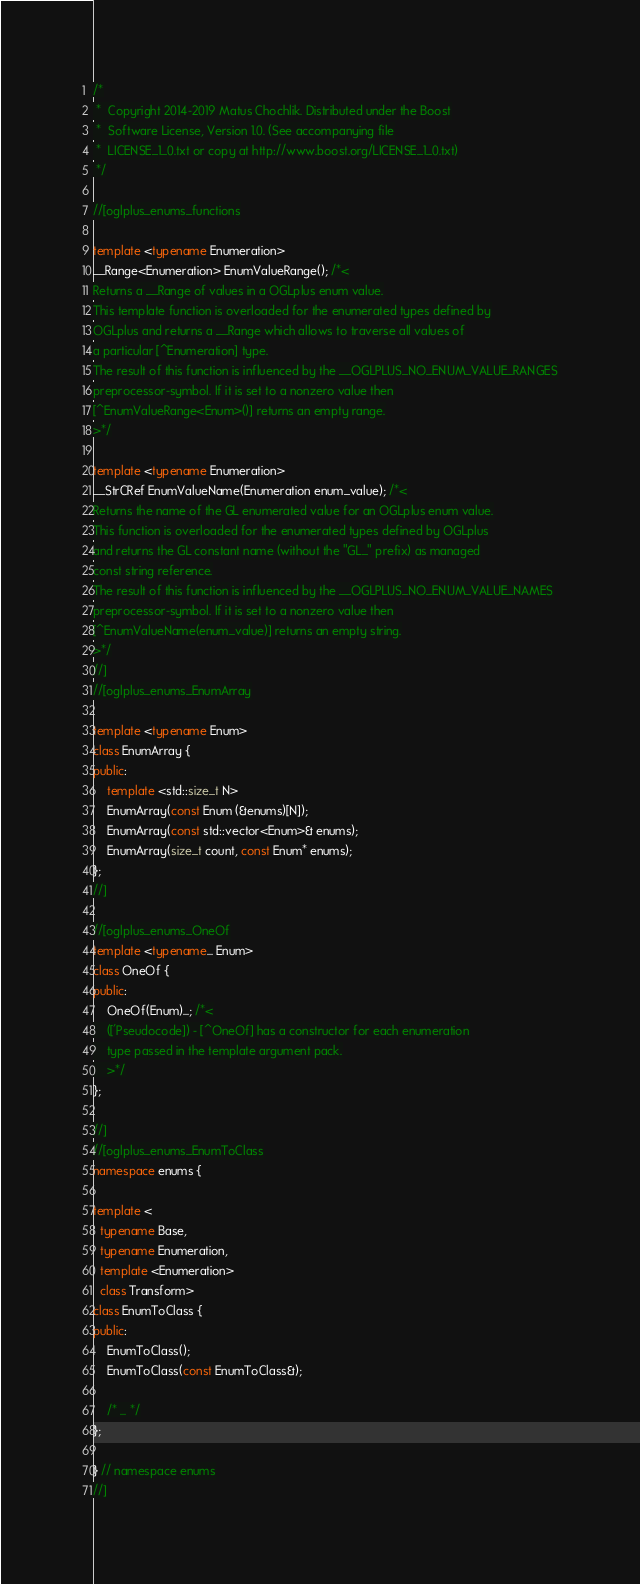<code> <loc_0><loc_0><loc_500><loc_500><_C++_>/*
 *  Copyright 2014-2019 Matus Chochlik. Distributed under the Boost
 *  Software License, Version 1.0. (See accompanying file
 *  LICENSE_1_0.txt or copy at http://www.boost.org/LICENSE_1_0.txt)
 */

//[oglplus_enums_functions

template <typename Enumeration>
__Range<Enumeration> EnumValueRange(); /*<
Returns a __Range of values in a OGLplus enum value.
This template function is overloaded for the enumerated types defined by
OGLplus and returns a __Range which allows to traverse all values of
a particular [^Enumeration] type.
The result of this function is influenced by the __OGLPLUS_NO_ENUM_VALUE_RANGES
preprocessor-symbol. If it is set to a nonzero value then
[^EnumValueRange<Enum>()] returns an empty range.
>*/

template <typename Enumeration>
__StrCRef EnumValueName(Enumeration enum_value); /*<
Returns the name of the GL enumerated value for an OGLplus enum value.
This function is overloaded for the enumerated types defined by OGLplus
and returns the GL constant name (without the "GL_" prefix) as managed
const string reference.
The result of this function is influenced by the __OGLPLUS_NO_ENUM_VALUE_NAMES
preprocessor-symbol. If it is set to a nonzero value then
[^EnumValueName(enum_value)] returns an empty string.
>*/
//]
//[oglplus_enums_EnumArray

template <typename Enum>
class EnumArray {
public:
    template <std::size_t N>
    EnumArray(const Enum (&enums)[N]);
    EnumArray(const std::vector<Enum>& enums);
    EnumArray(size_t count, const Enum* enums);
};
//]

//[oglplus_enums_OneOf
template <typename... Enum>
class OneOf {
public:
    OneOf(Enum)...; /*<
    (['Pseudocode]) - [^OneOf] has a constructor for each enumeration
    type passed in the template argument pack.
    >*/
};

//]
//[oglplus_enums_EnumToClass
namespace enums {

template <
  typename Base,
  typename Enumeration,
  template <Enumeration>
  class Transform>
class EnumToClass {
public:
    EnumToClass();
    EnumToClass(const EnumToClass&);

    /* ... */
};

} // namespace enums
//]
</code> 